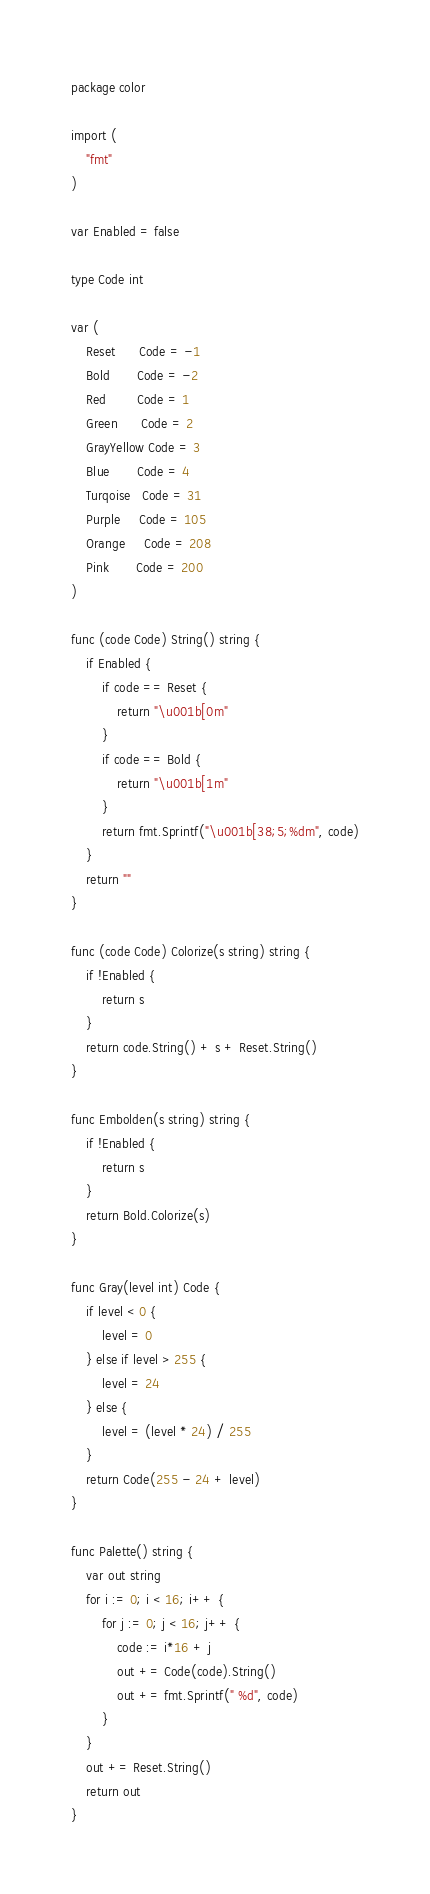<code> <loc_0><loc_0><loc_500><loc_500><_Go_>package color

import (
	"fmt"
)

var Enabled = false

type Code int

var (
	Reset      Code = -1
	Bold       Code = -2
	Red        Code = 1
	Green      Code = 2
	GrayYellow Code = 3
	Blue       Code = 4
	Turqoise   Code = 31
	Purple     Code = 105
	Orange     Code = 208
	Pink       Code = 200
)

func (code Code) String() string {
	if Enabled {
		if code == Reset {
			return "\u001b[0m"
		}
		if code == Bold {
			return "\u001b[1m"
		}
		return fmt.Sprintf("\u001b[38;5;%dm", code)
	}
	return ""
}

func (code Code) Colorize(s string) string {
	if !Enabled {
		return s
	}
	return code.String() + s + Reset.String()
}

func Embolden(s string) string {
	if !Enabled {
		return s
	}
	return Bold.Colorize(s)
}

func Gray(level int) Code {
	if level < 0 {
		level = 0
	} else if level > 255 {
		level = 24
	} else {
		level = (level * 24) / 255
	}
	return Code(255 - 24 + level)
}

func Palette() string {
	var out string
	for i := 0; i < 16; i++ {
		for j := 0; j < 16; j++ {
			code := i*16 + j
			out += Code(code).String()
			out += fmt.Sprintf(" %d", code)
		}
	}
	out += Reset.String()
	return out
}
</code> 